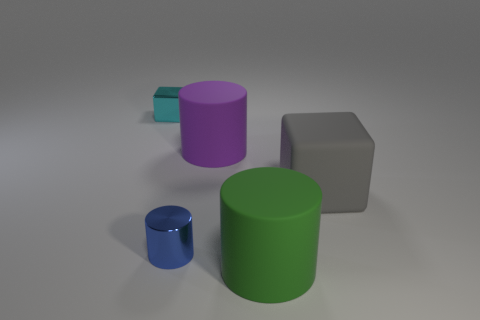Subtract all yellow blocks. Subtract all gray spheres. How many blocks are left? 2 Subtract all yellow spheres. How many red cylinders are left? 0 Add 4 things. How many large purples exist? 0 Subtract all rubber things. Subtract all blue metallic cylinders. How many objects are left? 1 Add 1 large green cylinders. How many large green cylinders are left? 2 Add 2 large things. How many large things exist? 5 Add 5 large things. How many objects exist? 10 Subtract all green cylinders. How many cylinders are left? 2 Subtract all large purple matte cylinders. How many cylinders are left? 2 Subtract 0 green spheres. How many objects are left? 5 